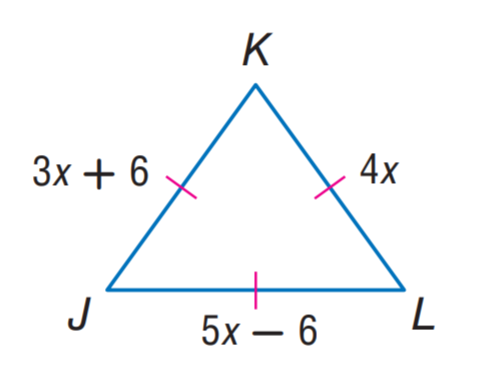Question: Find J K.
Choices:
A. 6
B. 18
C. 24
D. 42
Answer with the letter. Answer: C Question: Find K L.
Choices:
A. 6
B. 18
C. 24
D. 42
Answer with the letter. Answer: C 